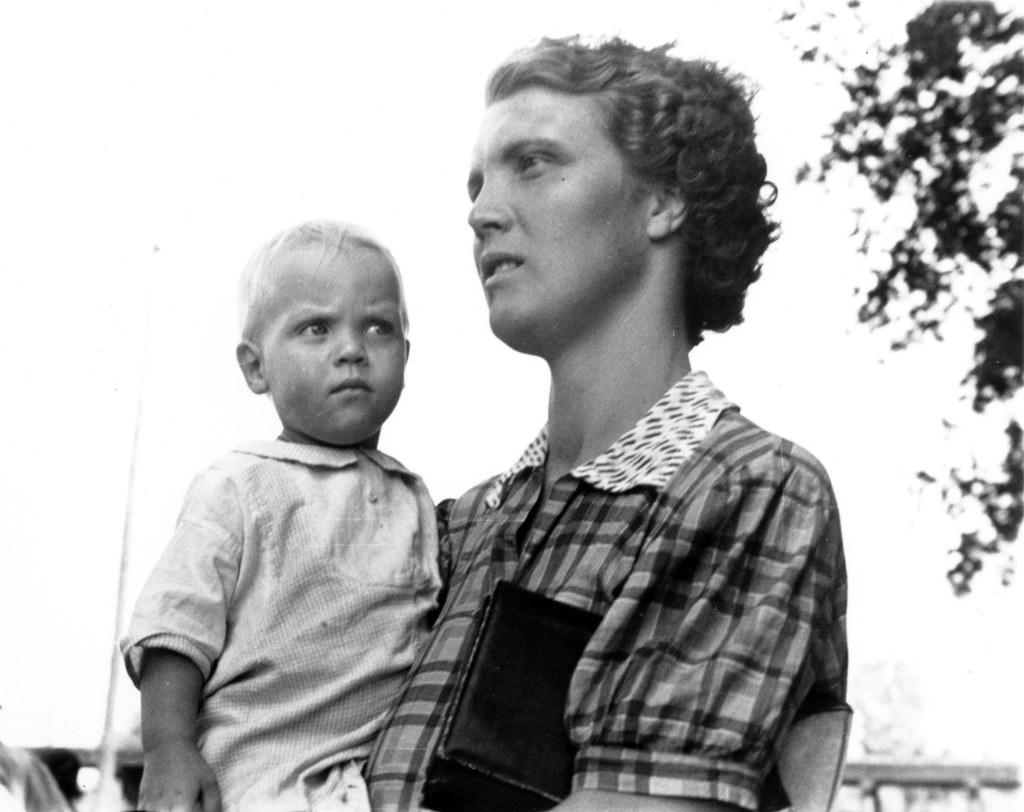Who is the main subject in the image? There is a man in the image. What is the man doing in the image? The man is holding a child. What is the man's posture in the image? The man is standing. What can be seen in the background of the image? There is a pole, railing, and the sky visible in the background of the image. What type of wax is being used by the man in the image? There is no wax present in the image; the man is holding a child. What drug is the child taking in the image? There is no drug present in the image; the man is simply holding the child. 